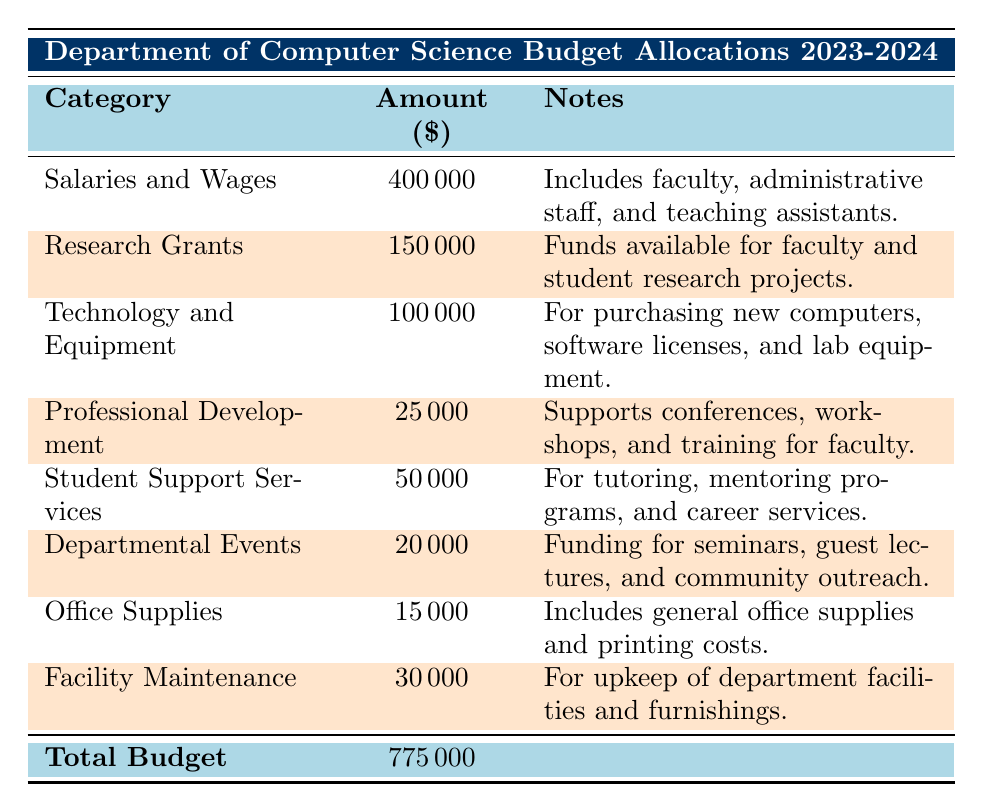What is the total budget allocation for the Department of Computer Science for the academic year 2023-2024? The table lists the total budget in the last row, showing an allocation of 775,000 dollars for the academic year 2023-2024.
Answer: 775000 How much is allocated for Salaries and Wages? The table specifies that the amount for Salaries and Wages is 400,000 dollars.
Answer: 400000 Is the amount allocated for Research Grants more than 100,000 dollars? The table shows that Research Grants are allocated 150,000 dollars, which is indeed more than 100,000 dollars.
Answer: Yes Calculate the combined total for Technology and Equipment, and Professional Development. The amount allocated for Technology and Equipment is 100,000 dollars, and for Professional Development, it is 25,000 dollars. Summing these gives 100,000 + 25,000 = 125,000 dollars.
Answer: 125000 How much is allocated for Student Support Services? Referring to the table, it states that 50,000 dollars are allocated for Student Support Services.
Answer: 50000 Is the total amount allocated for Office Supplies and Facility Maintenance greater than 50,000 dollars? The amount for Office Supplies is 15,000 dollars and for Facility Maintenance is 30,000 dollars. Adding these gives 15,000 + 30,000 = 45,000 dollars, which is not greater than 50,000 dollars.
Answer: No Determine the percentage of the total budget that goes to Professional Development. The amount for Professional Development is 25,000 dollars. To calculate the percentage of the total budget: (25,000 / 775,000) * 100 ≈ 3.23%.
Answer: 3.23% What is the difference in allocation between Research Grants and Departmental Events? Research Grants are allocated 150,000 dollars, while Departmental Events are allocated 20,000 dollars. The difference is 150,000 - 20,000 = 130,000 dollars.
Answer: 130000 Which category has the lowest budget allocation? The table shows that Office Supplies have the lowest allocation at 15,000 dollars, lower than all other categories.
Answer: Office Supplies How much is allocated for Facility Maintenance compared to the total budget? The allocation for Facility Maintenance is 30,000 dollars. To compare it to the total budget, we find that 30,000 is approximately 3.87% of the total budget of 775,000 dollars (30,000 / 775,000 * 100).
Answer: 3.87% 